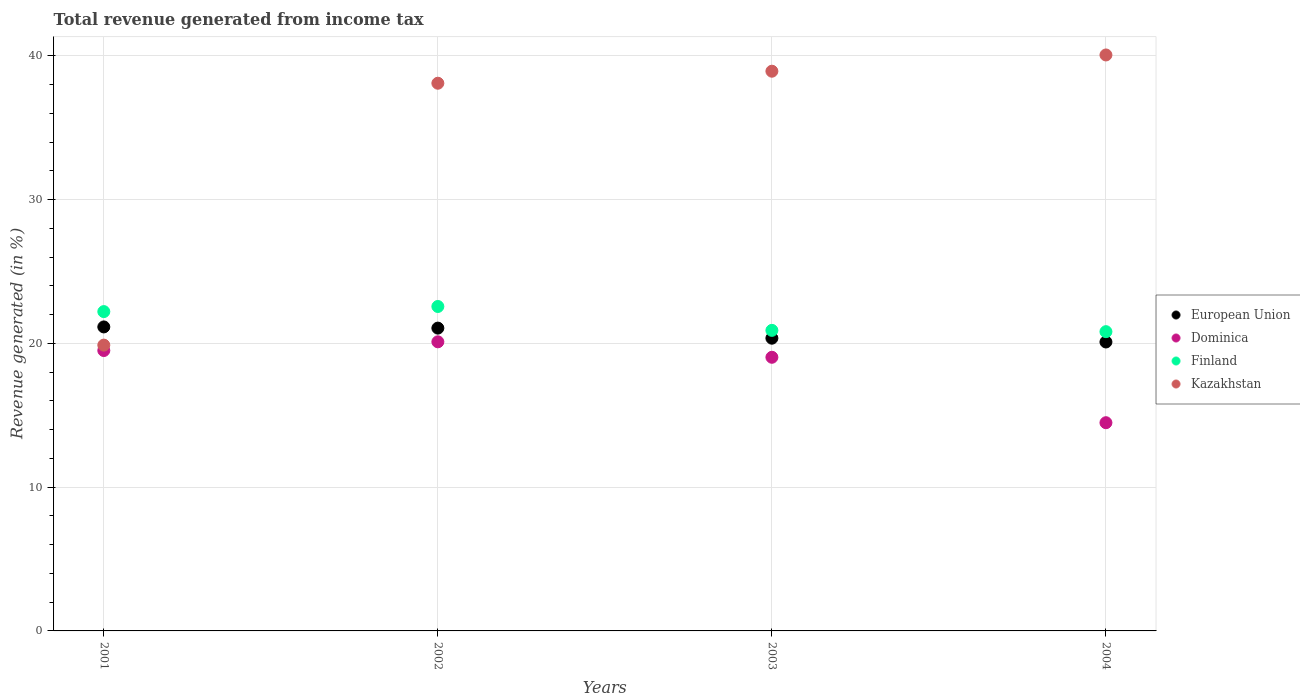How many different coloured dotlines are there?
Provide a succinct answer. 4. What is the total revenue generated in Kazakhstan in 2002?
Give a very brief answer. 38.09. Across all years, what is the maximum total revenue generated in Finland?
Your answer should be compact. 22.56. Across all years, what is the minimum total revenue generated in Dominica?
Offer a terse response. 14.48. In which year was the total revenue generated in European Union maximum?
Make the answer very short. 2001. What is the total total revenue generated in European Union in the graph?
Keep it short and to the point. 82.65. What is the difference between the total revenue generated in Kazakhstan in 2002 and that in 2003?
Your answer should be compact. -0.84. What is the difference between the total revenue generated in Finland in 2004 and the total revenue generated in European Union in 2002?
Make the answer very short. -0.25. What is the average total revenue generated in Dominica per year?
Your response must be concise. 18.28. In the year 2001, what is the difference between the total revenue generated in European Union and total revenue generated in Dominica?
Your response must be concise. 1.64. What is the ratio of the total revenue generated in European Union in 2001 to that in 2004?
Your answer should be compact. 1.05. Is the total revenue generated in Dominica in 2002 less than that in 2004?
Offer a very short reply. No. Is the difference between the total revenue generated in European Union in 2001 and 2004 greater than the difference between the total revenue generated in Dominica in 2001 and 2004?
Ensure brevity in your answer.  No. What is the difference between the highest and the second highest total revenue generated in Dominica?
Provide a succinct answer. 0.61. What is the difference between the highest and the lowest total revenue generated in Finland?
Offer a terse response. 1.75. In how many years, is the total revenue generated in Kazakhstan greater than the average total revenue generated in Kazakhstan taken over all years?
Ensure brevity in your answer.  3. Is it the case that in every year, the sum of the total revenue generated in Dominica and total revenue generated in Kazakhstan  is greater than the sum of total revenue generated in Finland and total revenue generated in European Union?
Offer a terse response. Yes. Is it the case that in every year, the sum of the total revenue generated in Finland and total revenue generated in Kazakhstan  is greater than the total revenue generated in European Union?
Give a very brief answer. Yes. Does the total revenue generated in Dominica monotonically increase over the years?
Make the answer very short. No. Is the total revenue generated in Dominica strictly greater than the total revenue generated in Finland over the years?
Offer a terse response. No. Is the total revenue generated in European Union strictly less than the total revenue generated in Dominica over the years?
Offer a terse response. No. How many years are there in the graph?
Ensure brevity in your answer.  4. Are the values on the major ticks of Y-axis written in scientific E-notation?
Your answer should be compact. No. Does the graph contain grids?
Your answer should be very brief. Yes. How many legend labels are there?
Your answer should be compact. 4. What is the title of the graph?
Ensure brevity in your answer.  Total revenue generated from income tax. Does "Gambia, The" appear as one of the legend labels in the graph?
Offer a terse response. No. What is the label or title of the X-axis?
Your answer should be very brief. Years. What is the label or title of the Y-axis?
Keep it short and to the point. Revenue generated (in %). What is the Revenue generated (in %) in European Union in 2001?
Your response must be concise. 21.14. What is the Revenue generated (in %) in Dominica in 2001?
Offer a very short reply. 19.5. What is the Revenue generated (in %) in Finland in 2001?
Your answer should be compact. 22.21. What is the Revenue generated (in %) in Kazakhstan in 2001?
Keep it short and to the point. 19.88. What is the Revenue generated (in %) in European Union in 2002?
Offer a very short reply. 21.06. What is the Revenue generated (in %) of Dominica in 2002?
Provide a succinct answer. 20.11. What is the Revenue generated (in %) in Finland in 2002?
Make the answer very short. 22.56. What is the Revenue generated (in %) of Kazakhstan in 2002?
Your answer should be very brief. 38.09. What is the Revenue generated (in %) of European Union in 2003?
Your answer should be very brief. 20.36. What is the Revenue generated (in %) in Dominica in 2003?
Make the answer very short. 19.03. What is the Revenue generated (in %) in Finland in 2003?
Offer a very short reply. 20.9. What is the Revenue generated (in %) of Kazakhstan in 2003?
Your answer should be compact. 38.93. What is the Revenue generated (in %) of European Union in 2004?
Your answer should be compact. 20.09. What is the Revenue generated (in %) in Dominica in 2004?
Provide a short and direct response. 14.48. What is the Revenue generated (in %) of Finland in 2004?
Offer a very short reply. 20.81. What is the Revenue generated (in %) in Kazakhstan in 2004?
Your answer should be compact. 40.06. Across all years, what is the maximum Revenue generated (in %) in European Union?
Offer a terse response. 21.14. Across all years, what is the maximum Revenue generated (in %) in Dominica?
Give a very brief answer. 20.11. Across all years, what is the maximum Revenue generated (in %) of Finland?
Give a very brief answer. 22.56. Across all years, what is the maximum Revenue generated (in %) in Kazakhstan?
Offer a very short reply. 40.06. Across all years, what is the minimum Revenue generated (in %) in European Union?
Provide a short and direct response. 20.09. Across all years, what is the minimum Revenue generated (in %) of Dominica?
Your answer should be very brief. 14.48. Across all years, what is the minimum Revenue generated (in %) of Finland?
Your answer should be very brief. 20.81. Across all years, what is the minimum Revenue generated (in %) of Kazakhstan?
Provide a short and direct response. 19.88. What is the total Revenue generated (in %) in European Union in the graph?
Make the answer very short. 82.65. What is the total Revenue generated (in %) of Dominica in the graph?
Make the answer very short. 73.12. What is the total Revenue generated (in %) in Finland in the graph?
Provide a short and direct response. 86.49. What is the total Revenue generated (in %) of Kazakhstan in the graph?
Ensure brevity in your answer.  136.95. What is the difference between the Revenue generated (in %) in European Union in 2001 and that in 2002?
Your answer should be compact. 0.08. What is the difference between the Revenue generated (in %) of Dominica in 2001 and that in 2002?
Offer a very short reply. -0.61. What is the difference between the Revenue generated (in %) of Finland in 2001 and that in 2002?
Your answer should be compact. -0.36. What is the difference between the Revenue generated (in %) in Kazakhstan in 2001 and that in 2002?
Give a very brief answer. -18.21. What is the difference between the Revenue generated (in %) of European Union in 2001 and that in 2003?
Keep it short and to the point. 0.78. What is the difference between the Revenue generated (in %) of Dominica in 2001 and that in 2003?
Keep it short and to the point. 0.47. What is the difference between the Revenue generated (in %) of Finland in 2001 and that in 2003?
Offer a terse response. 1.31. What is the difference between the Revenue generated (in %) of Kazakhstan in 2001 and that in 2003?
Make the answer very short. -19.05. What is the difference between the Revenue generated (in %) in European Union in 2001 and that in 2004?
Ensure brevity in your answer.  1.05. What is the difference between the Revenue generated (in %) of Dominica in 2001 and that in 2004?
Offer a very short reply. 5.02. What is the difference between the Revenue generated (in %) in Finland in 2001 and that in 2004?
Provide a short and direct response. 1.4. What is the difference between the Revenue generated (in %) in Kazakhstan in 2001 and that in 2004?
Provide a succinct answer. -20.18. What is the difference between the Revenue generated (in %) of European Union in 2002 and that in 2003?
Give a very brief answer. 0.7. What is the difference between the Revenue generated (in %) of Dominica in 2002 and that in 2003?
Ensure brevity in your answer.  1.07. What is the difference between the Revenue generated (in %) of Finland in 2002 and that in 2003?
Provide a short and direct response. 1.66. What is the difference between the Revenue generated (in %) of Kazakhstan in 2002 and that in 2003?
Your answer should be compact. -0.84. What is the difference between the Revenue generated (in %) of European Union in 2002 and that in 2004?
Ensure brevity in your answer.  0.96. What is the difference between the Revenue generated (in %) of Dominica in 2002 and that in 2004?
Provide a succinct answer. 5.63. What is the difference between the Revenue generated (in %) of Finland in 2002 and that in 2004?
Your answer should be compact. 1.75. What is the difference between the Revenue generated (in %) of Kazakhstan in 2002 and that in 2004?
Your response must be concise. -1.97. What is the difference between the Revenue generated (in %) in European Union in 2003 and that in 2004?
Offer a very short reply. 0.26. What is the difference between the Revenue generated (in %) of Dominica in 2003 and that in 2004?
Offer a terse response. 4.55. What is the difference between the Revenue generated (in %) in Finland in 2003 and that in 2004?
Keep it short and to the point. 0.09. What is the difference between the Revenue generated (in %) of Kazakhstan in 2003 and that in 2004?
Offer a very short reply. -1.13. What is the difference between the Revenue generated (in %) in European Union in 2001 and the Revenue generated (in %) in Dominica in 2002?
Your answer should be compact. 1.04. What is the difference between the Revenue generated (in %) of European Union in 2001 and the Revenue generated (in %) of Finland in 2002?
Give a very brief answer. -1.42. What is the difference between the Revenue generated (in %) of European Union in 2001 and the Revenue generated (in %) of Kazakhstan in 2002?
Keep it short and to the point. -16.95. What is the difference between the Revenue generated (in %) of Dominica in 2001 and the Revenue generated (in %) of Finland in 2002?
Make the answer very short. -3.06. What is the difference between the Revenue generated (in %) of Dominica in 2001 and the Revenue generated (in %) of Kazakhstan in 2002?
Your answer should be very brief. -18.59. What is the difference between the Revenue generated (in %) in Finland in 2001 and the Revenue generated (in %) in Kazakhstan in 2002?
Your answer should be very brief. -15.88. What is the difference between the Revenue generated (in %) in European Union in 2001 and the Revenue generated (in %) in Dominica in 2003?
Offer a very short reply. 2.11. What is the difference between the Revenue generated (in %) in European Union in 2001 and the Revenue generated (in %) in Finland in 2003?
Your answer should be very brief. 0.24. What is the difference between the Revenue generated (in %) of European Union in 2001 and the Revenue generated (in %) of Kazakhstan in 2003?
Offer a very short reply. -17.78. What is the difference between the Revenue generated (in %) of Dominica in 2001 and the Revenue generated (in %) of Finland in 2003?
Your answer should be compact. -1.4. What is the difference between the Revenue generated (in %) in Dominica in 2001 and the Revenue generated (in %) in Kazakhstan in 2003?
Offer a terse response. -19.43. What is the difference between the Revenue generated (in %) in Finland in 2001 and the Revenue generated (in %) in Kazakhstan in 2003?
Your answer should be compact. -16.72. What is the difference between the Revenue generated (in %) of European Union in 2001 and the Revenue generated (in %) of Dominica in 2004?
Keep it short and to the point. 6.66. What is the difference between the Revenue generated (in %) in European Union in 2001 and the Revenue generated (in %) in Finland in 2004?
Ensure brevity in your answer.  0.33. What is the difference between the Revenue generated (in %) in European Union in 2001 and the Revenue generated (in %) in Kazakhstan in 2004?
Offer a very short reply. -18.91. What is the difference between the Revenue generated (in %) of Dominica in 2001 and the Revenue generated (in %) of Finland in 2004?
Ensure brevity in your answer.  -1.31. What is the difference between the Revenue generated (in %) of Dominica in 2001 and the Revenue generated (in %) of Kazakhstan in 2004?
Offer a terse response. -20.56. What is the difference between the Revenue generated (in %) of Finland in 2001 and the Revenue generated (in %) of Kazakhstan in 2004?
Give a very brief answer. -17.85. What is the difference between the Revenue generated (in %) in European Union in 2002 and the Revenue generated (in %) in Dominica in 2003?
Offer a very short reply. 2.03. What is the difference between the Revenue generated (in %) of European Union in 2002 and the Revenue generated (in %) of Finland in 2003?
Offer a terse response. 0.16. What is the difference between the Revenue generated (in %) of European Union in 2002 and the Revenue generated (in %) of Kazakhstan in 2003?
Give a very brief answer. -17.87. What is the difference between the Revenue generated (in %) of Dominica in 2002 and the Revenue generated (in %) of Finland in 2003?
Give a very brief answer. -0.8. What is the difference between the Revenue generated (in %) in Dominica in 2002 and the Revenue generated (in %) in Kazakhstan in 2003?
Give a very brief answer. -18.82. What is the difference between the Revenue generated (in %) in Finland in 2002 and the Revenue generated (in %) in Kazakhstan in 2003?
Offer a very short reply. -16.36. What is the difference between the Revenue generated (in %) in European Union in 2002 and the Revenue generated (in %) in Dominica in 2004?
Keep it short and to the point. 6.58. What is the difference between the Revenue generated (in %) in European Union in 2002 and the Revenue generated (in %) in Finland in 2004?
Give a very brief answer. 0.25. What is the difference between the Revenue generated (in %) in European Union in 2002 and the Revenue generated (in %) in Kazakhstan in 2004?
Your response must be concise. -19. What is the difference between the Revenue generated (in %) in Dominica in 2002 and the Revenue generated (in %) in Finland in 2004?
Your answer should be compact. -0.71. What is the difference between the Revenue generated (in %) in Dominica in 2002 and the Revenue generated (in %) in Kazakhstan in 2004?
Make the answer very short. -19.95. What is the difference between the Revenue generated (in %) in Finland in 2002 and the Revenue generated (in %) in Kazakhstan in 2004?
Give a very brief answer. -17.49. What is the difference between the Revenue generated (in %) in European Union in 2003 and the Revenue generated (in %) in Dominica in 2004?
Ensure brevity in your answer.  5.88. What is the difference between the Revenue generated (in %) of European Union in 2003 and the Revenue generated (in %) of Finland in 2004?
Your response must be concise. -0.45. What is the difference between the Revenue generated (in %) in European Union in 2003 and the Revenue generated (in %) in Kazakhstan in 2004?
Provide a short and direct response. -19.7. What is the difference between the Revenue generated (in %) of Dominica in 2003 and the Revenue generated (in %) of Finland in 2004?
Provide a succinct answer. -1.78. What is the difference between the Revenue generated (in %) of Dominica in 2003 and the Revenue generated (in %) of Kazakhstan in 2004?
Provide a succinct answer. -21.03. What is the difference between the Revenue generated (in %) of Finland in 2003 and the Revenue generated (in %) of Kazakhstan in 2004?
Your answer should be very brief. -19.15. What is the average Revenue generated (in %) of European Union per year?
Give a very brief answer. 20.66. What is the average Revenue generated (in %) in Dominica per year?
Your answer should be compact. 18.28. What is the average Revenue generated (in %) in Finland per year?
Your answer should be compact. 21.62. What is the average Revenue generated (in %) in Kazakhstan per year?
Ensure brevity in your answer.  34.24. In the year 2001, what is the difference between the Revenue generated (in %) in European Union and Revenue generated (in %) in Dominica?
Provide a short and direct response. 1.64. In the year 2001, what is the difference between the Revenue generated (in %) in European Union and Revenue generated (in %) in Finland?
Ensure brevity in your answer.  -1.07. In the year 2001, what is the difference between the Revenue generated (in %) of European Union and Revenue generated (in %) of Kazakhstan?
Make the answer very short. 1.27. In the year 2001, what is the difference between the Revenue generated (in %) in Dominica and Revenue generated (in %) in Finland?
Your response must be concise. -2.71. In the year 2001, what is the difference between the Revenue generated (in %) in Dominica and Revenue generated (in %) in Kazakhstan?
Give a very brief answer. -0.38. In the year 2001, what is the difference between the Revenue generated (in %) in Finland and Revenue generated (in %) in Kazakhstan?
Your response must be concise. 2.33. In the year 2002, what is the difference between the Revenue generated (in %) of European Union and Revenue generated (in %) of Dominica?
Your answer should be compact. 0.95. In the year 2002, what is the difference between the Revenue generated (in %) in European Union and Revenue generated (in %) in Finland?
Provide a succinct answer. -1.5. In the year 2002, what is the difference between the Revenue generated (in %) of European Union and Revenue generated (in %) of Kazakhstan?
Provide a short and direct response. -17.03. In the year 2002, what is the difference between the Revenue generated (in %) of Dominica and Revenue generated (in %) of Finland?
Ensure brevity in your answer.  -2.46. In the year 2002, what is the difference between the Revenue generated (in %) in Dominica and Revenue generated (in %) in Kazakhstan?
Make the answer very short. -17.98. In the year 2002, what is the difference between the Revenue generated (in %) of Finland and Revenue generated (in %) of Kazakhstan?
Your response must be concise. -15.53. In the year 2003, what is the difference between the Revenue generated (in %) in European Union and Revenue generated (in %) in Dominica?
Your answer should be compact. 1.33. In the year 2003, what is the difference between the Revenue generated (in %) of European Union and Revenue generated (in %) of Finland?
Offer a very short reply. -0.55. In the year 2003, what is the difference between the Revenue generated (in %) of European Union and Revenue generated (in %) of Kazakhstan?
Offer a terse response. -18.57. In the year 2003, what is the difference between the Revenue generated (in %) in Dominica and Revenue generated (in %) in Finland?
Keep it short and to the point. -1.87. In the year 2003, what is the difference between the Revenue generated (in %) of Dominica and Revenue generated (in %) of Kazakhstan?
Your response must be concise. -19.9. In the year 2003, what is the difference between the Revenue generated (in %) of Finland and Revenue generated (in %) of Kazakhstan?
Give a very brief answer. -18.02. In the year 2004, what is the difference between the Revenue generated (in %) of European Union and Revenue generated (in %) of Dominica?
Ensure brevity in your answer.  5.61. In the year 2004, what is the difference between the Revenue generated (in %) in European Union and Revenue generated (in %) in Finland?
Make the answer very short. -0.72. In the year 2004, what is the difference between the Revenue generated (in %) of European Union and Revenue generated (in %) of Kazakhstan?
Your answer should be compact. -19.96. In the year 2004, what is the difference between the Revenue generated (in %) of Dominica and Revenue generated (in %) of Finland?
Offer a terse response. -6.33. In the year 2004, what is the difference between the Revenue generated (in %) in Dominica and Revenue generated (in %) in Kazakhstan?
Provide a short and direct response. -25.58. In the year 2004, what is the difference between the Revenue generated (in %) of Finland and Revenue generated (in %) of Kazakhstan?
Ensure brevity in your answer.  -19.24. What is the ratio of the Revenue generated (in %) of European Union in 2001 to that in 2002?
Provide a succinct answer. 1. What is the ratio of the Revenue generated (in %) in Dominica in 2001 to that in 2002?
Ensure brevity in your answer.  0.97. What is the ratio of the Revenue generated (in %) in Finland in 2001 to that in 2002?
Keep it short and to the point. 0.98. What is the ratio of the Revenue generated (in %) of Kazakhstan in 2001 to that in 2002?
Offer a very short reply. 0.52. What is the ratio of the Revenue generated (in %) in European Union in 2001 to that in 2003?
Make the answer very short. 1.04. What is the ratio of the Revenue generated (in %) of Dominica in 2001 to that in 2003?
Provide a short and direct response. 1.02. What is the ratio of the Revenue generated (in %) of Finland in 2001 to that in 2003?
Your response must be concise. 1.06. What is the ratio of the Revenue generated (in %) in Kazakhstan in 2001 to that in 2003?
Offer a terse response. 0.51. What is the ratio of the Revenue generated (in %) in European Union in 2001 to that in 2004?
Give a very brief answer. 1.05. What is the ratio of the Revenue generated (in %) in Dominica in 2001 to that in 2004?
Your response must be concise. 1.35. What is the ratio of the Revenue generated (in %) of Finland in 2001 to that in 2004?
Ensure brevity in your answer.  1.07. What is the ratio of the Revenue generated (in %) in Kazakhstan in 2001 to that in 2004?
Keep it short and to the point. 0.5. What is the ratio of the Revenue generated (in %) in European Union in 2002 to that in 2003?
Keep it short and to the point. 1.03. What is the ratio of the Revenue generated (in %) in Dominica in 2002 to that in 2003?
Offer a very short reply. 1.06. What is the ratio of the Revenue generated (in %) of Finland in 2002 to that in 2003?
Offer a terse response. 1.08. What is the ratio of the Revenue generated (in %) of Kazakhstan in 2002 to that in 2003?
Keep it short and to the point. 0.98. What is the ratio of the Revenue generated (in %) in European Union in 2002 to that in 2004?
Make the answer very short. 1.05. What is the ratio of the Revenue generated (in %) in Dominica in 2002 to that in 2004?
Ensure brevity in your answer.  1.39. What is the ratio of the Revenue generated (in %) in Finland in 2002 to that in 2004?
Your response must be concise. 1.08. What is the ratio of the Revenue generated (in %) of Kazakhstan in 2002 to that in 2004?
Your response must be concise. 0.95. What is the ratio of the Revenue generated (in %) in European Union in 2003 to that in 2004?
Provide a short and direct response. 1.01. What is the ratio of the Revenue generated (in %) of Dominica in 2003 to that in 2004?
Make the answer very short. 1.31. What is the ratio of the Revenue generated (in %) in Finland in 2003 to that in 2004?
Provide a short and direct response. 1. What is the ratio of the Revenue generated (in %) in Kazakhstan in 2003 to that in 2004?
Ensure brevity in your answer.  0.97. What is the difference between the highest and the second highest Revenue generated (in %) in European Union?
Provide a short and direct response. 0.08. What is the difference between the highest and the second highest Revenue generated (in %) in Dominica?
Offer a terse response. 0.61. What is the difference between the highest and the second highest Revenue generated (in %) in Finland?
Your response must be concise. 0.36. What is the difference between the highest and the second highest Revenue generated (in %) of Kazakhstan?
Give a very brief answer. 1.13. What is the difference between the highest and the lowest Revenue generated (in %) in European Union?
Your answer should be very brief. 1.05. What is the difference between the highest and the lowest Revenue generated (in %) in Dominica?
Offer a terse response. 5.63. What is the difference between the highest and the lowest Revenue generated (in %) of Finland?
Keep it short and to the point. 1.75. What is the difference between the highest and the lowest Revenue generated (in %) of Kazakhstan?
Keep it short and to the point. 20.18. 